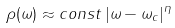<formula> <loc_0><loc_0><loc_500><loc_500>\rho ( \omega ) \approx c o n s t \, | \omega - \omega _ { c } | ^ { \eta }</formula> 